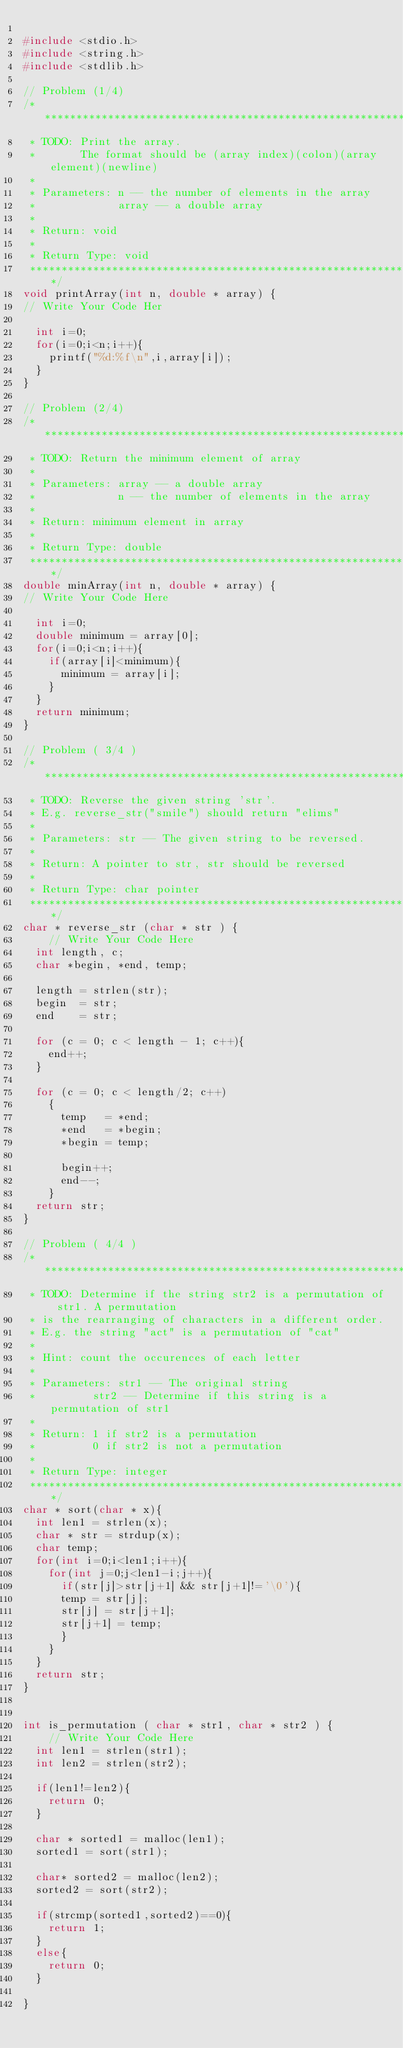<code> <loc_0><loc_0><loc_500><loc_500><_C_>
#include <stdio.h>
#include <string.h>
#include <stdlib.h>

// Problem (1/4)
/******************************************************************************
 * TODO: Print the array.
 *       The format should be (array index)(colon)(array element)(newline) 
 * 
 * Parameters: n -- the number of elements in the array
 *             array -- a double array
 *
 * Return: void 
 *
 * Return Type: void
 *****************************************************************************/
void printArray(int n, double * array) {
// Write Your Code Her

  int i=0;
  for(i=0;i<n;i++){
    printf("%d:%f\n",i,array[i]);
  }
}

// Problem (2/4)
/******************************************************************************
 * TODO: Return the minimum element of array 
 * 
 * Parameters: array -- a double array
 *             n -- the number of elements in the array
 *
 * Return: minimum element in array 
 *
 * Return Type: double
 *****************************************************************************/
double minArray(int n, double * array) {
// Write Your Code Here

  int i=0;
  double minimum = array[0];
  for(i=0;i<n;i++){
    if(array[i]<minimum){
      minimum = array[i];
    }
  }
  return minimum;
}

// Problem ( 3/4 ) 
/******************************************************************************
 * TODO: Reverse the given string 'str'. 
 * E.g. reverse_str("smile") should return "elims"
 * 
 * Parameters: str -- The given string to be reversed.
 *
 * Return: A pointer to str, str should be reversed 
 *
 * Return Type: char pointer
 *****************************************************************************/
char * reverse_str (char * str ) {
    // Write Your Code Here
  int length, c;
  char *begin, *end, temp;

  length = strlen(str);
  begin  = str;
  end    = str;

  for (c = 0; c < length - 1; c++){
    end++;
  }

  for (c = 0; c < length/2; c++)
    {
      temp   = *end;
      *end   = *begin;
      *begin = temp;

      begin++;
      end--;
    }
  return str;
}

// Problem ( 4/4 ) 
/******************************************************************************
 * TODO: Determine if the string str2 is a permutation of str1. A permutation
 * is the rearranging of characters in a different order. 
 * E.g. the string "act" is a permutation of "cat" 
 *
 * Hint: count the occurences of each letter
 * 
 * Parameters: str1 -- The original string
 *	       str2 -- Determine if this string is a permutation of str1 
 *
 * Return: 1 if str2 is a permutation
 *         0 if str2 is not a permutation
 *
 * Return Type: integer
 *****************************************************************************/
char * sort(char * x){
  int len1 = strlen(x);
  char * str = strdup(x);
  char temp;
  for(int i=0;i<len1;i++){
    for(int j=0;j<len1-i;j++){
      if(str[j]>str[j+1] && str[j+1]!='\0'){
	  temp = str[j];
	  str[j] = str[j+1];
	  str[j+1] = temp;
      }
    }
  }
  return str;
}
      

int is_permutation ( char * str1, char * str2 ) {
    // Write Your Code Here
  int len1 = strlen(str1);
  int len2 = strlen(str2);

  if(len1!=len2){
    return 0;
  }

  char * sorted1 = malloc(len1);
  sorted1 = sort(str1);

  char* sorted2 = malloc(len2);
  sorted2 = sort(str2);

  if(strcmp(sorted1,sorted2)==0){
    return 1;
  }
  else{
    return 0;
  }
			  
}
</code> 